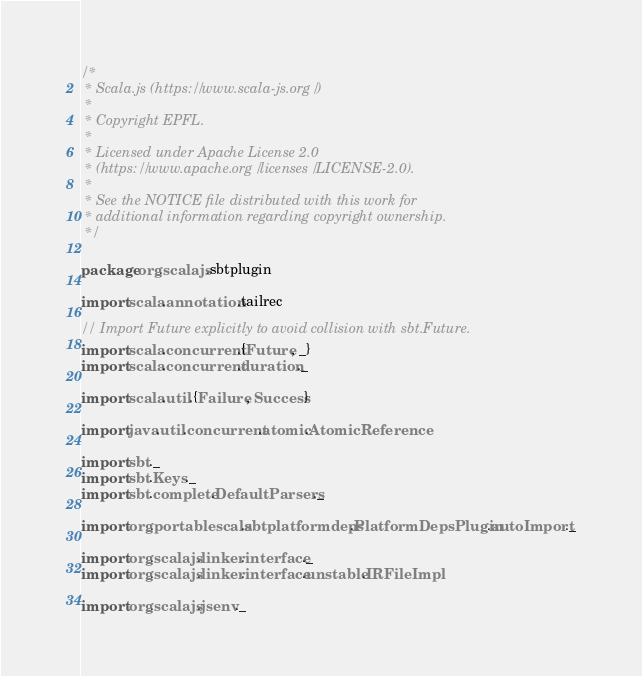<code> <loc_0><loc_0><loc_500><loc_500><_Scala_>/*
 * Scala.js (https://www.scala-js.org/)
 *
 * Copyright EPFL.
 *
 * Licensed under Apache License 2.0
 * (https://www.apache.org/licenses/LICENSE-2.0).
 *
 * See the NOTICE file distributed with this work for
 * additional information regarding copyright ownership.
 */

package org.scalajs.sbtplugin

import scala.annotation.tailrec

// Import Future explicitly to avoid collision with sbt.Future.
import scala.concurrent.{Future, _}
import scala.concurrent.duration._

import scala.util.{Failure, Success}

import java.util.concurrent.atomic.AtomicReference

import sbt._
import sbt.Keys._
import sbt.complete.DefaultParsers._

import org.portablescala.sbtplatformdeps.PlatformDepsPlugin.autoImport._

import org.scalajs.linker.interface._
import org.scalajs.linker.interface.unstable.IRFileImpl

import org.scalajs.jsenv._
</code> 